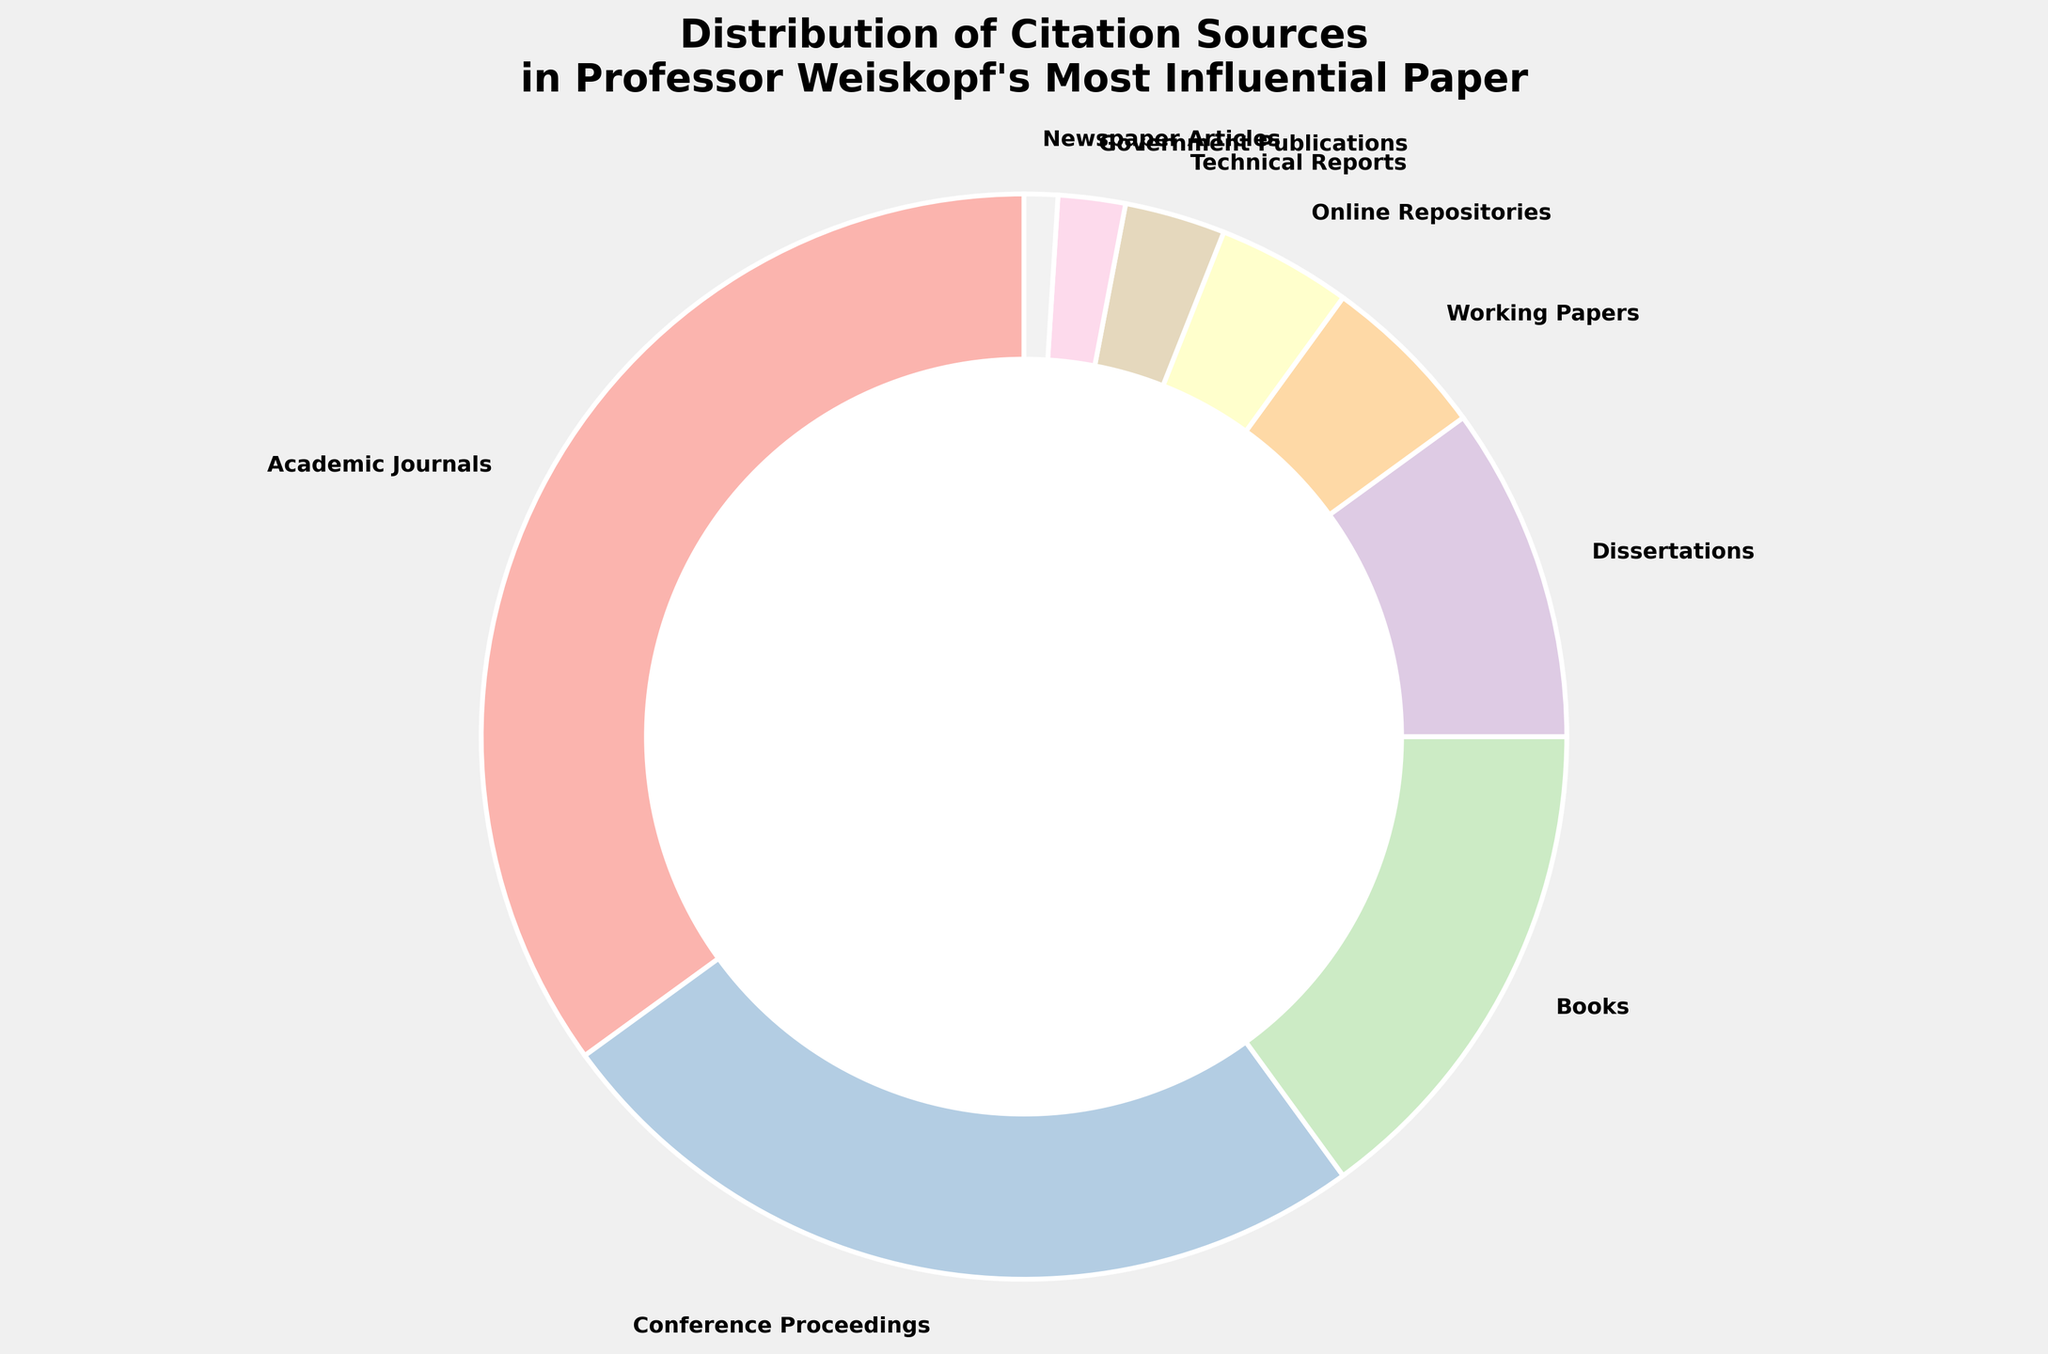What is the largest citation source in Professor Weiskopf's paper? The pie chart shows that "Academic Journals" have the largest portion.
Answer: Academic Journals What is the sum of the percentages for Books, Dissertations, and Working Papers? Add the percentages of Books (15%), Dissertations (10%), and Working Papers (5%) together. 15 + 10 + 5 = 30
Answer: 30 Which citation sources have the same color range in the chart? The pie chart uses pastel colors that smoothly transition; sources close to each other have similar shades such as "Academic Journals" and "Conference Proceedings" in varying pastel shades.
Answer: Similar pastel shades Which citation sources together make up exactly half of the total citations? Sum the percentages of sources and compare if they reach 50%. "Academic Journals" (35%) and "Conference Proceedings" (25%) combined give 60%, while "Books" (15%) + "Dissertations" (10%) + "Working Papers" (5%) = 30%. "Academic Journals" (35%) + "Dissertations" (10%) + "Working Papers" (5%) = 50%.
Answer: Academic Journals, Dissertations, and Working Papers What is the percentage difference between the highest and lowest citation sources? Subtract the percentage of the lowest citation source (Newspaper Articles) from the highest (Academic Journals). 35 - 1 = 34
Answer: 34 Which citation source occupies the smallest area in the pie chart? The pie chart indicates "Newspaper Articles" with 1%, the smallest percentage.
Answer: Newspaper Articles How do the combined citation percentages of Online Repositories and Technical Reports compare to Books? Sum the percentages of Online Repositories (4%) and Technical Reports (3%), and compare with Books (15%). 4 + 3 = 7, which is less than 15.
Answer: Less than Books What is the total percentage occupied by sources other than Academic Journals and Conference Proceedings? Sum the percentages of all sources except Academic Journals (35%) and Conference Proceedings (25%). The total is 100 - 35 - 25 = 40.
Answer: 40 Identify the sources that appear in pastel colors in the pie chart. The pie chart utilizes pastel colors for all the sections, meaning "Academic Journals", "Conference Proceedings", "Books", etc., are all in pastel shades.
Answer: All sources Is the percentage of citations from Books more or less than half of the citations from Academic Journals? The percentage of citations from Books is 15%, and half of Academic Journals' citations is 35/2 = 17.5. 15 is less than 17.5.
Answer: Less 